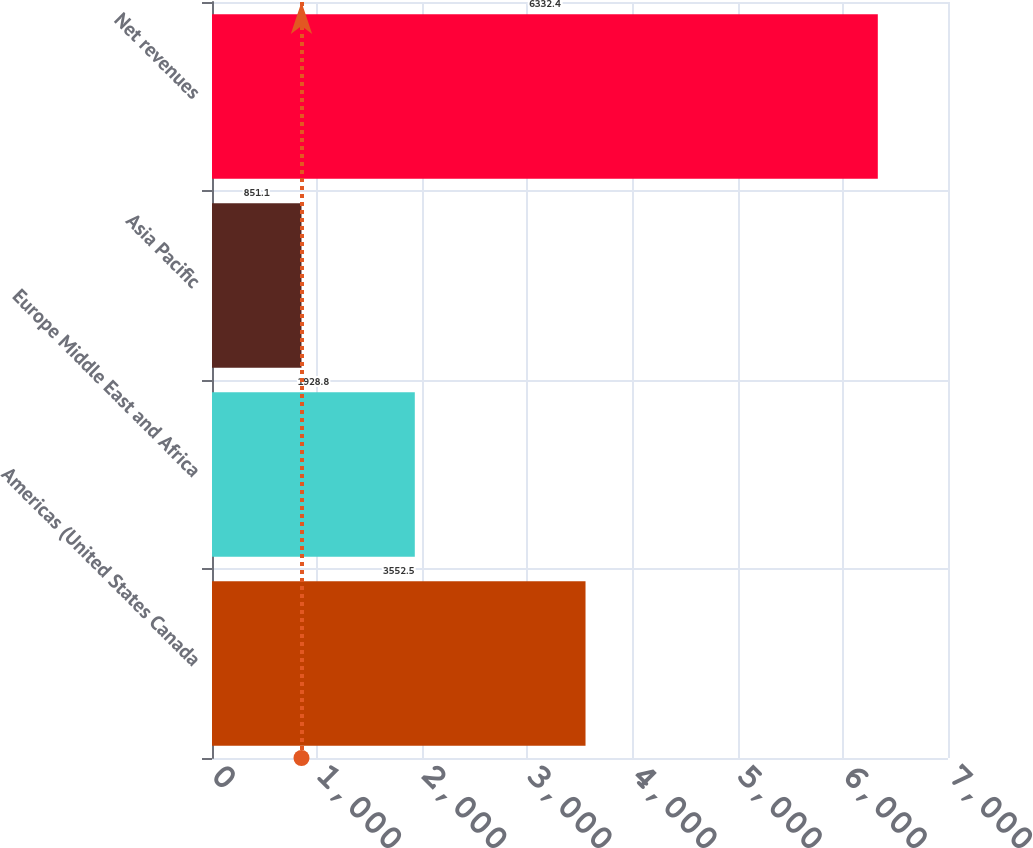Convert chart. <chart><loc_0><loc_0><loc_500><loc_500><bar_chart><fcel>Americas (United States Canada<fcel>Europe Middle East and Africa<fcel>Asia Pacific<fcel>Net revenues<nl><fcel>3552.5<fcel>1928.8<fcel>851.1<fcel>6332.4<nl></chart> 